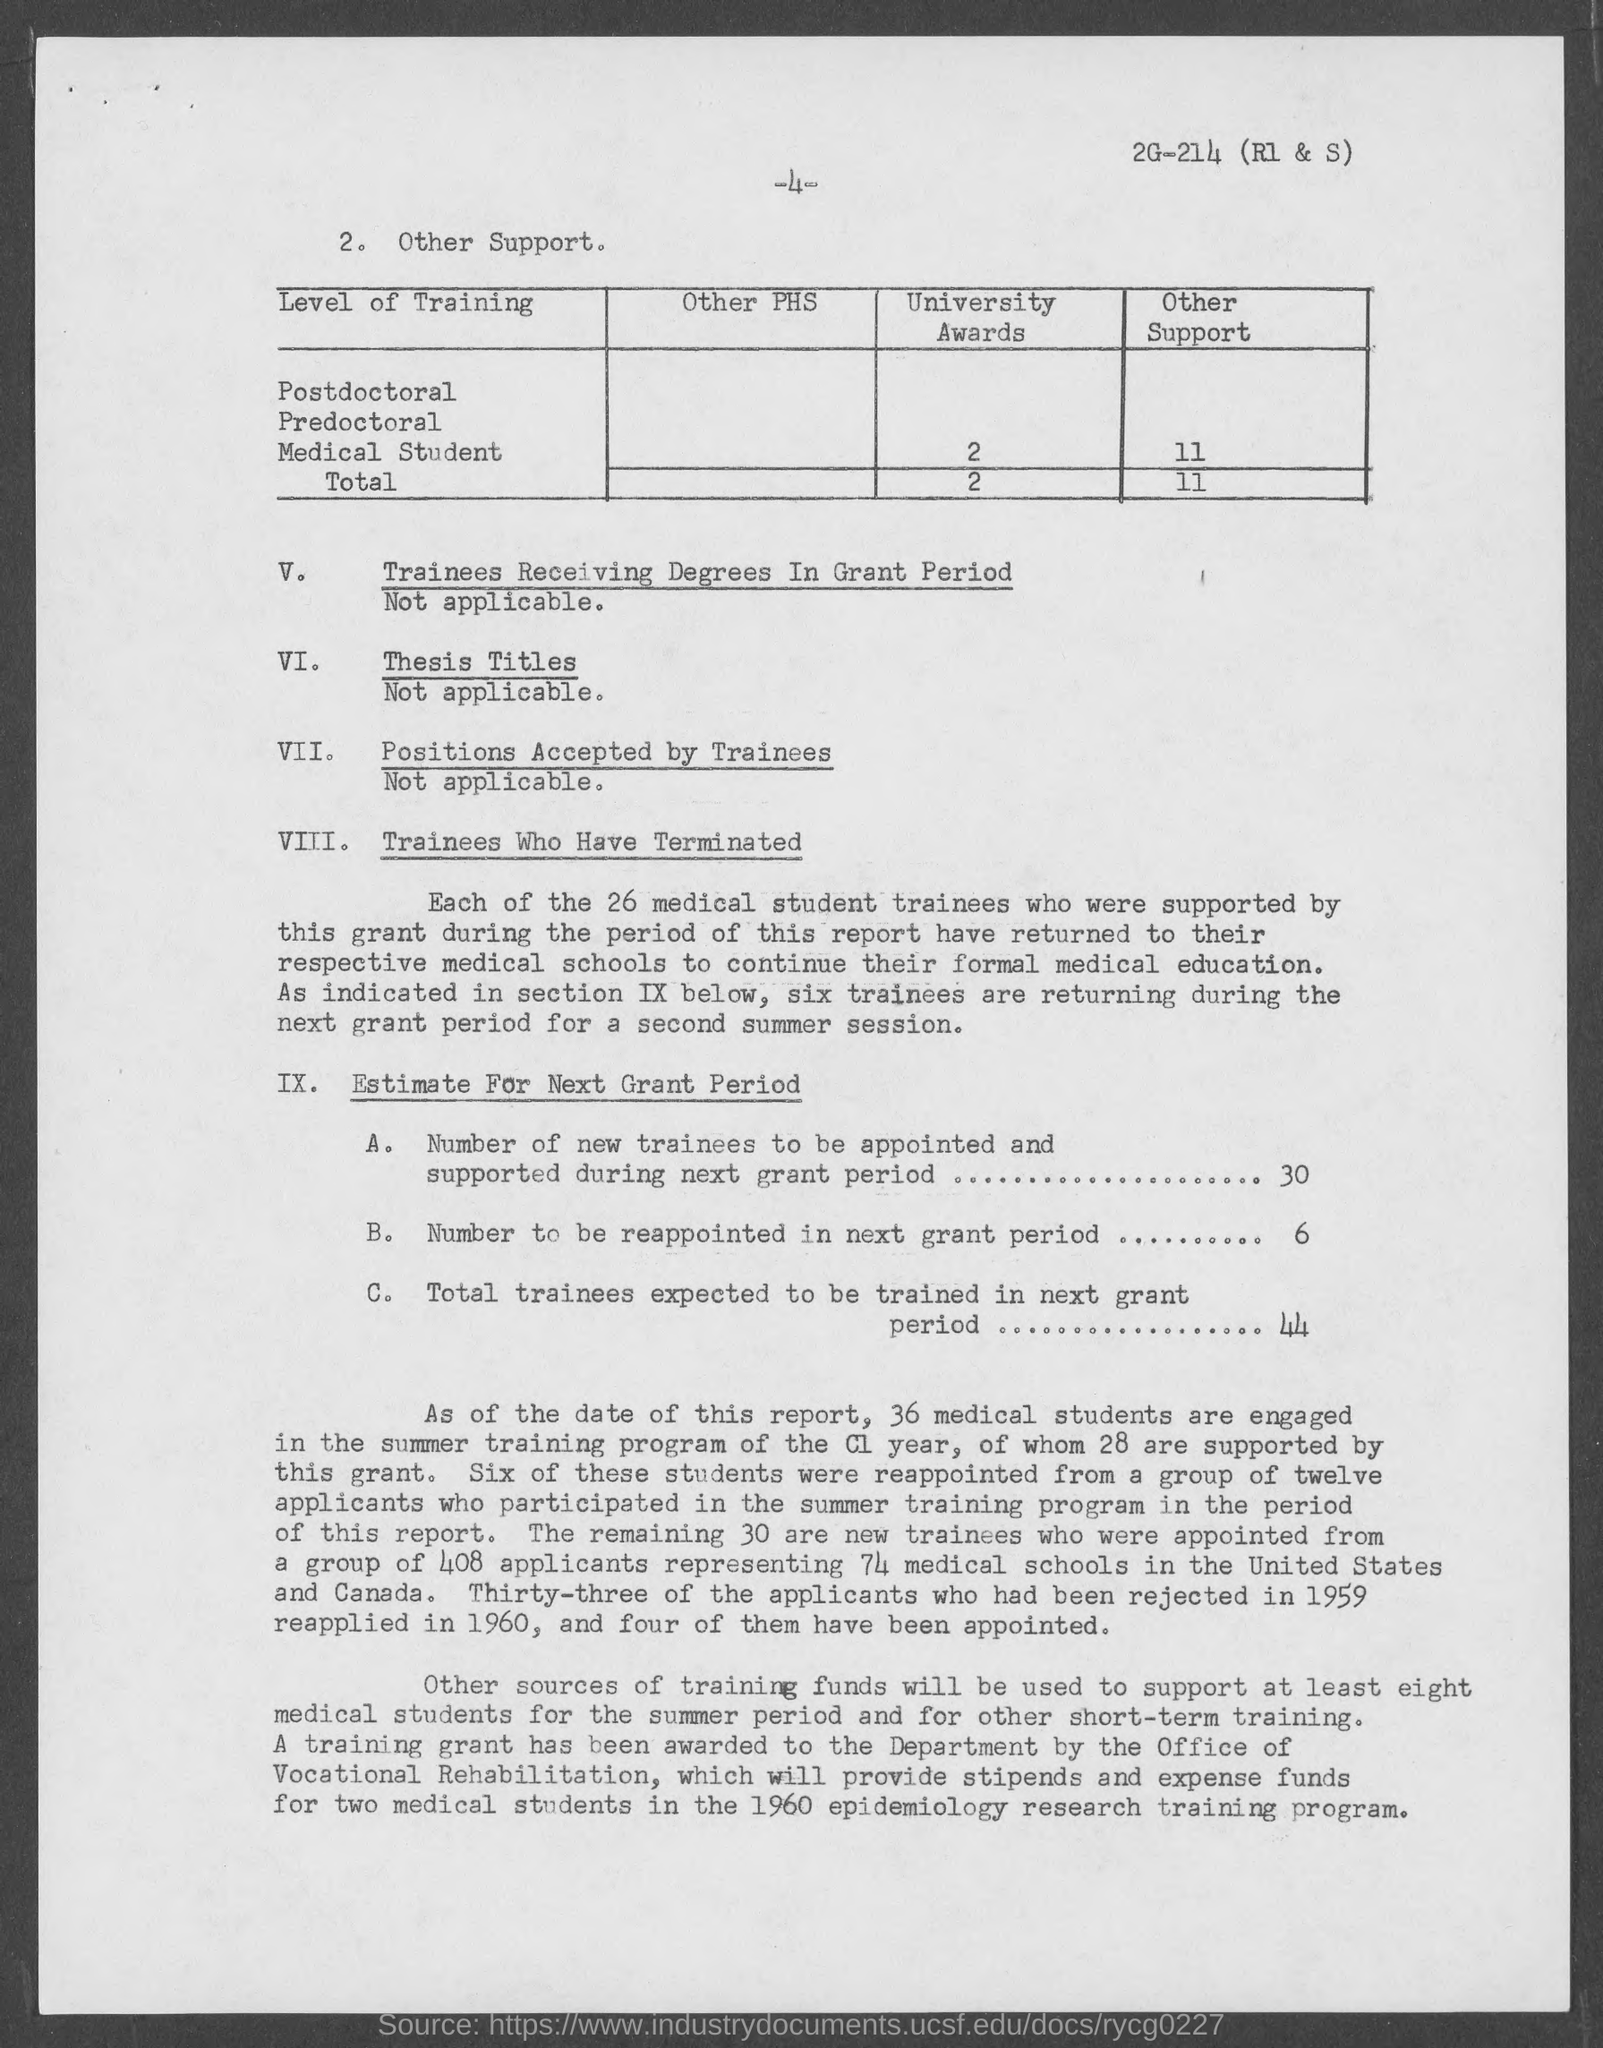How many new trainees to be appointed and supported for next grant period ?
Provide a short and direct response. 30. How many number of people to be reappointed in the next grant period ?
Keep it short and to the point. 6. What is the total number of University awards ?
Make the answer very short. 2. 